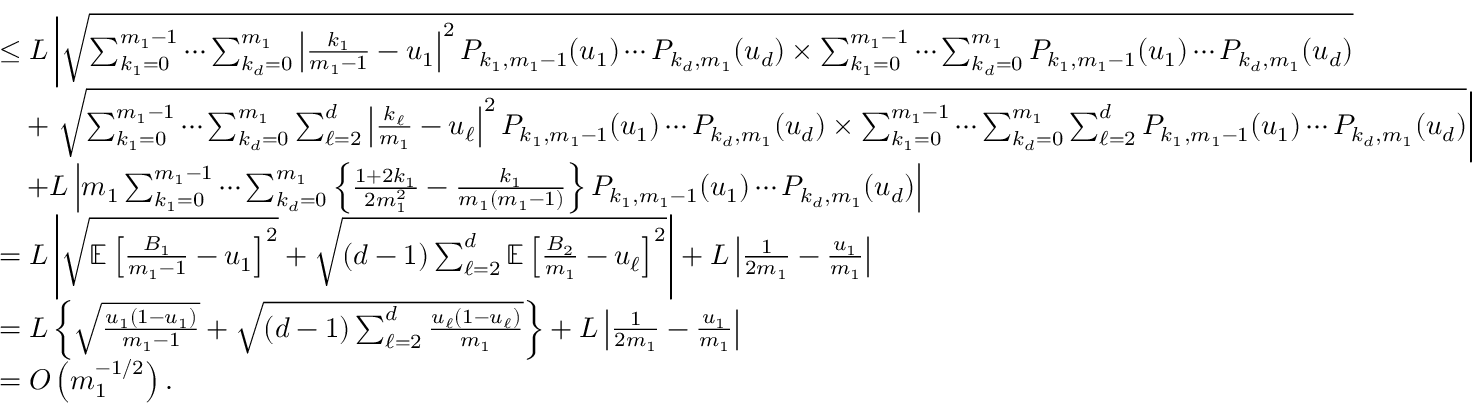<formula> <loc_0><loc_0><loc_500><loc_500>\begin{array} { r l } & { \leq L \left | \sqrt { \sum _ { k _ { 1 } = 0 } ^ { m _ { 1 } - 1 } \cdots \sum _ { k _ { d } = 0 } ^ { m _ { 1 } } \left | \frac { k _ { 1 } } { m _ { 1 } - 1 } - u _ { 1 } \right | ^ { 2 } P _ { k _ { 1 } , m _ { 1 } - 1 } ( u _ { 1 } ) \cdots P _ { k _ { d } , m _ { 1 } } ( u _ { d } ) \times \sum _ { k _ { 1 } = 0 } ^ { m _ { 1 } - 1 } \cdots \sum _ { k _ { d } = 0 } ^ { m _ { 1 } } P _ { k _ { 1 } , m _ { 1 } - 1 } ( u _ { 1 } ) \cdots P _ { k _ { d } , m _ { 1 } } ( u _ { d } ) } } \\ & { \quad + \sqrt { \sum _ { k _ { 1 } = 0 } ^ { m _ { 1 } - 1 } \cdots \sum _ { k _ { d } = 0 } ^ { m _ { 1 } } \sum _ { \ell = 2 } ^ { d } \left | \frac { k _ { \ell } } { m _ { 1 } } - u _ { \ell } \right | ^ { 2 } P _ { k _ { 1 } , m _ { 1 } - 1 } ( u _ { 1 } ) \cdots P _ { k _ { d } , m _ { 1 } } ( u _ { d } ) \times \sum _ { k _ { 1 } = 0 } ^ { m _ { 1 } - 1 } \cdots \sum _ { k _ { d } = 0 } ^ { m _ { 1 } } \sum _ { \ell = 2 } ^ { d } P _ { k _ { 1 } , m _ { 1 } - 1 } ( u _ { 1 } ) \cdots P _ { k _ { d } , m _ { 1 } } ( u _ { d } ) } \right | } \\ & { \quad + L \left | m _ { 1 } \sum _ { k _ { 1 } = 0 } ^ { m _ { 1 } - 1 } \cdots \sum _ { k _ { d } = 0 } ^ { m _ { 1 } } \left \{ \frac { 1 + 2 k _ { 1 } } { 2 m _ { 1 } ^ { 2 } } - \frac { k _ { 1 } } { m _ { 1 } ( m _ { 1 } - 1 ) } \right \} P _ { k _ { 1 } , m _ { 1 } - 1 } ( u _ { 1 } ) \cdots P _ { k _ { d } , m _ { 1 } } ( u _ { d } ) \right | } \\ & { = L \left | \sqrt { { \mathbb { E } } \left [ \frac { B _ { 1 } } { m _ { 1 } - 1 } - u _ { 1 } \right ] ^ { 2 } } + \sqrt { ( d - 1 ) \sum _ { \ell = 2 } ^ { d } { \mathbb { E } } \left [ \frac { B _ { 2 } } { m _ { 1 } } - u _ { \ell } \right ] ^ { 2 } } \right | + L \left | \frac { 1 } { 2 m _ { 1 } } - \frac { u _ { 1 } } { m _ { 1 } } \right | } \\ & { = L \left \{ \sqrt { \frac { u _ { 1 } ( 1 - u _ { 1 } ) } { m _ { 1 } - 1 } } + \sqrt { ( d - 1 ) \sum _ { \ell = 2 } ^ { d } \frac { u _ { \ell } ( 1 - u _ { \ell } ) } { m _ { 1 } } } \right \} + L \left | \frac { 1 } { 2 m _ { 1 } } - \frac { u _ { 1 } } { m _ { 1 } } \right | } \\ & { = O \left ( m _ { 1 } ^ { - 1 / 2 } \right ) . } \end{array}</formula> 